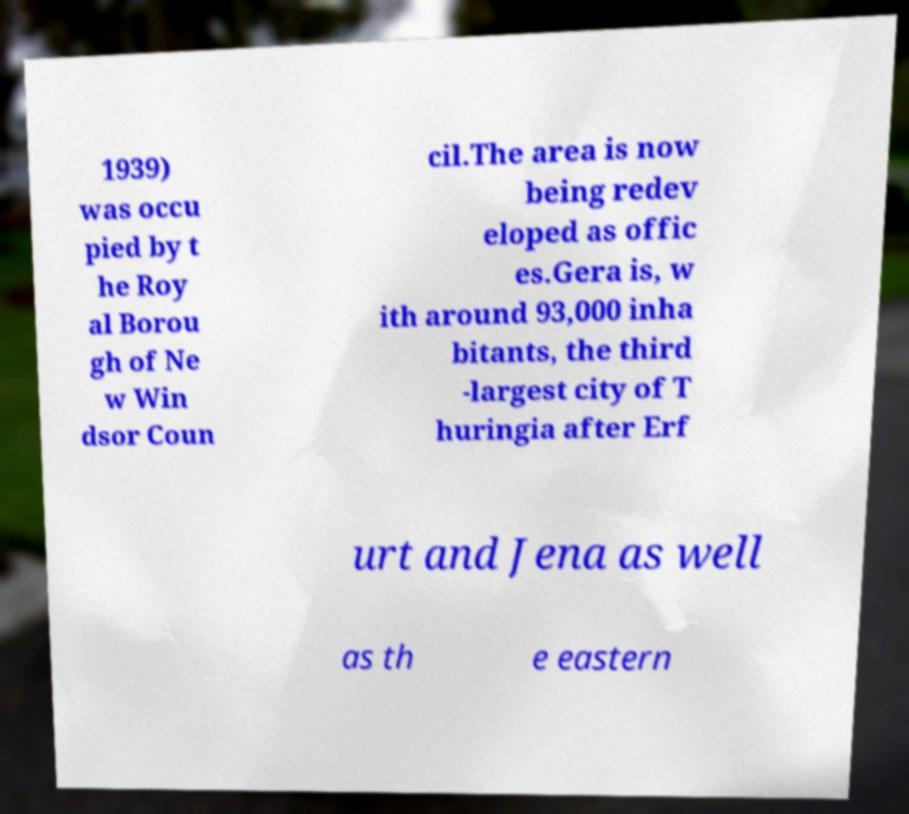For documentation purposes, I need the text within this image transcribed. Could you provide that? 1939) was occu pied by t he Roy al Borou gh of Ne w Win dsor Coun cil.The area is now being redev eloped as offic es.Gera is, w ith around 93,000 inha bitants, the third -largest city of T huringia after Erf urt and Jena as well as th e eastern 